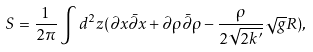<formula> <loc_0><loc_0><loc_500><loc_500>S = \frac { 1 } { 2 \pi } \int d ^ { 2 } z ( \partial x \bar { \partial } x + \partial \rho \bar { \partial } \rho - \frac { \rho } { 2 \sqrt { 2 k ^ { \prime } } } \sqrt { g } R ) ,</formula> 